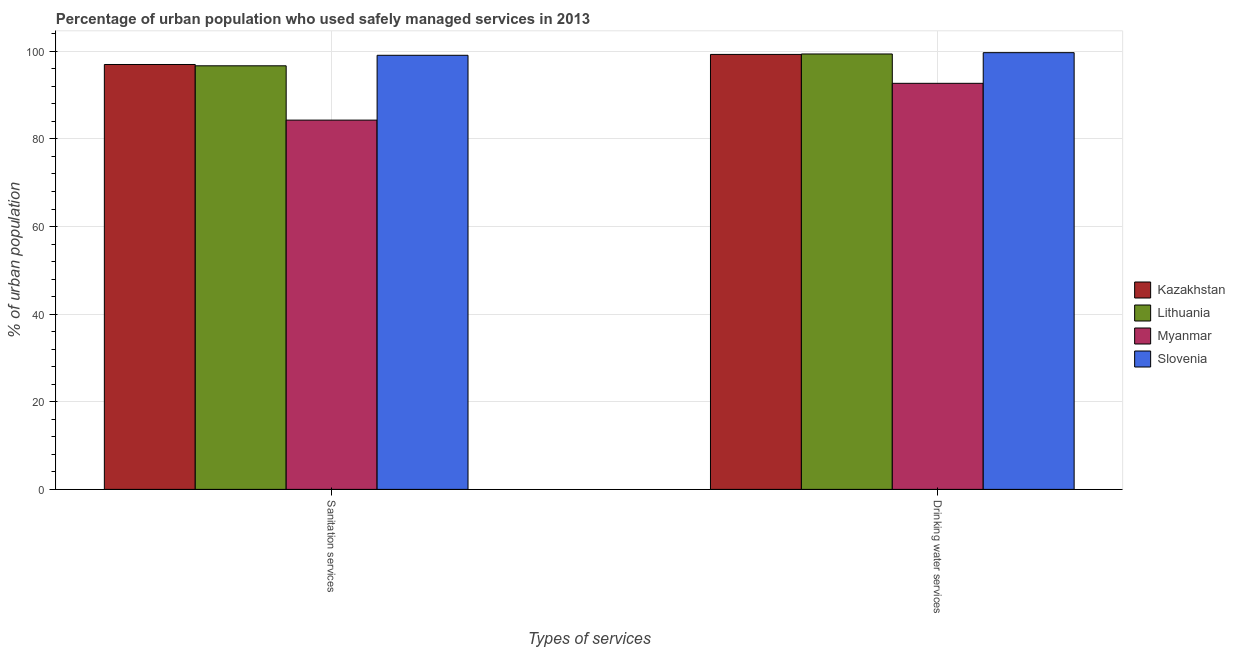How many different coloured bars are there?
Your answer should be very brief. 4. How many groups of bars are there?
Your answer should be compact. 2. Are the number of bars per tick equal to the number of legend labels?
Ensure brevity in your answer.  Yes. Are the number of bars on each tick of the X-axis equal?
Your answer should be very brief. Yes. How many bars are there on the 1st tick from the right?
Ensure brevity in your answer.  4. What is the label of the 1st group of bars from the left?
Your answer should be compact. Sanitation services. What is the percentage of urban population who used drinking water services in Lithuania?
Give a very brief answer. 99.4. Across all countries, what is the maximum percentage of urban population who used sanitation services?
Give a very brief answer. 99.1. Across all countries, what is the minimum percentage of urban population who used drinking water services?
Keep it short and to the point. 92.7. In which country was the percentage of urban population who used sanitation services maximum?
Offer a terse response. Slovenia. In which country was the percentage of urban population who used sanitation services minimum?
Ensure brevity in your answer.  Myanmar. What is the total percentage of urban population who used drinking water services in the graph?
Give a very brief answer. 391.1. What is the difference between the percentage of urban population who used drinking water services in Slovenia and that in Lithuania?
Ensure brevity in your answer.  0.3. What is the difference between the percentage of urban population who used drinking water services in Kazakhstan and the percentage of urban population who used sanitation services in Slovenia?
Your response must be concise. 0.2. What is the average percentage of urban population who used drinking water services per country?
Your answer should be compact. 97.77. What is the difference between the percentage of urban population who used sanitation services and percentage of urban population who used drinking water services in Lithuania?
Keep it short and to the point. -2.7. What is the ratio of the percentage of urban population who used drinking water services in Myanmar to that in Slovenia?
Your answer should be compact. 0.93. What does the 3rd bar from the left in Sanitation services represents?
Ensure brevity in your answer.  Myanmar. What does the 3rd bar from the right in Drinking water services represents?
Give a very brief answer. Lithuania. What is the difference between two consecutive major ticks on the Y-axis?
Offer a very short reply. 20. Are the values on the major ticks of Y-axis written in scientific E-notation?
Ensure brevity in your answer.  No. Does the graph contain any zero values?
Your response must be concise. No. How many legend labels are there?
Your answer should be very brief. 4. How are the legend labels stacked?
Offer a terse response. Vertical. What is the title of the graph?
Your answer should be very brief. Percentage of urban population who used safely managed services in 2013. Does "Brazil" appear as one of the legend labels in the graph?
Offer a terse response. No. What is the label or title of the X-axis?
Give a very brief answer. Types of services. What is the label or title of the Y-axis?
Make the answer very short. % of urban population. What is the % of urban population in Kazakhstan in Sanitation services?
Give a very brief answer. 97. What is the % of urban population of Lithuania in Sanitation services?
Provide a short and direct response. 96.7. What is the % of urban population of Myanmar in Sanitation services?
Make the answer very short. 84.3. What is the % of urban population of Slovenia in Sanitation services?
Your response must be concise. 99.1. What is the % of urban population of Kazakhstan in Drinking water services?
Provide a short and direct response. 99.3. What is the % of urban population in Lithuania in Drinking water services?
Offer a very short reply. 99.4. What is the % of urban population of Myanmar in Drinking water services?
Give a very brief answer. 92.7. What is the % of urban population in Slovenia in Drinking water services?
Your response must be concise. 99.7. Across all Types of services, what is the maximum % of urban population in Kazakhstan?
Ensure brevity in your answer.  99.3. Across all Types of services, what is the maximum % of urban population of Lithuania?
Provide a short and direct response. 99.4. Across all Types of services, what is the maximum % of urban population of Myanmar?
Provide a succinct answer. 92.7. Across all Types of services, what is the maximum % of urban population in Slovenia?
Your answer should be very brief. 99.7. Across all Types of services, what is the minimum % of urban population in Kazakhstan?
Your answer should be very brief. 97. Across all Types of services, what is the minimum % of urban population of Lithuania?
Provide a short and direct response. 96.7. Across all Types of services, what is the minimum % of urban population of Myanmar?
Keep it short and to the point. 84.3. Across all Types of services, what is the minimum % of urban population in Slovenia?
Provide a succinct answer. 99.1. What is the total % of urban population of Kazakhstan in the graph?
Make the answer very short. 196.3. What is the total % of urban population of Lithuania in the graph?
Make the answer very short. 196.1. What is the total % of urban population in Myanmar in the graph?
Make the answer very short. 177. What is the total % of urban population in Slovenia in the graph?
Offer a very short reply. 198.8. What is the difference between the % of urban population in Lithuania in Sanitation services and that in Drinking water services?
Your answer should be compact. -2.7. What is the difference between the % of urban population in Kazakhstan in Sanitation services and the % of urban population in Myanmar in Drinking water services?
Your answer should be compact. 4.3. What is the difference between the % of urban population of Kazakhstan in Sanitation services and the % of urban population of Slovenia in Drinking water services?
Provide a succinct answer. -2.7. What is the difference between the % of urban population of Lithuania in Sanitation services and the % of urban population of Myanmar in Drinking water services?
Your answer should be very brief. 4. What is the difference between the % of urban population in Lithuania in Sanitation services and the % of urban population in Slovenia in Drinking water services?
Offer a very short reply. -3. What is the difference between the % of urban population of Myanmar in Sanitation services and the % of urban population of Slovenia in Drinking water services?
Offer a terse response. -15.4. What is the average % of urban population in Kazakhstan per Types of services?
Make the answer very short. 98.15. What is the average % of urban population of Lithuania per Types of services?
Give a very brief answer. 98.05. What is the average % of urban population of Myanmar per Types of services?
Give a very brief answer. 88.5. What is the average % of urban population of Slovenia per Types of services?
Offer a very short reply. 99.4. What is the difference between the % of urban population in Kazakhstan and % of urban population in Lithuania in Sanitation services?
Give a very brief answer. 0.3. What is the difference between the % of urban population in Kazakhstan and % of urban population in Myanmar in Sanitation services?
Ensure brevity in your answer.  12.7. What is the difference between the % of urban population in Kazakhstan and % of urban population in Slovenia in Sanitation services?
Your answer should be very brief. -2.1. What is the difference between the % of urban population in Myanmar and % of urban population in Slovenia in Sanitation services?
Provide a short and direct response. -14.8. What is the difference between the % of urban population in Kazakhstan and % of urban population in Lithuania in Drinking water services?
Offer a terse response. -0.1. What is the difference between the % of urban population of Kazakhstan and % of urban population of Myanmar in Drinking water services?
Keep it short and to the point. 6.6. What is the difference between the % of urban population of Kazakhstan and % of urban population of Slovenia in Drinking water services?
Provide a succinct answer. -0.4. What is the difference between the % of urban population of Lithuania and % of urban population of Myanmar in Drinking water services?
Provide a short and direct response. 6.7. What is the difference between the % of urban population in Lithuania and % of urban population in Slovenia in Drinking water services?
Offer a very short reply. -0.3. What is the difference between the % of urban population in Myanmar and % of urban population in Slovenia in Drinking water services?
Offer a terse response. -7. What is the ratio of the % of urban population in Kazakhstan in Sanitation services to that in Drinking water services?
Offer a very short reply. 0.98. What is the ratio of the % of urban population in Lithuania in Sanitation services to that in Drinking water services?
Keep it short and to the point. 0.97. What is the ratio of the % of urban population of Myanmar in Sanitation services to that in Drinking water services?
Make the answer very short. 0.91. What is the ratio of the % of urban population of Slovenia in Sanitation services to that in Drinking water services?
Offer a very short reply. 0.99. What is the difference between the highest and the second highest % of urban population in Lithuania?
Provide a short and direct response. 2.7. What is the difference between the highest and the second highest % of urban population in Myanmar?
Provide a short and direct response. 8.4. What is the difference between the highest and the second highest % of urban population of Slovenia?
Your response must be concise. 0.6. What is the difference between the highest and the lowest % of urban population of Kazakhstan?
Provide a short and direct response. 2.3. 